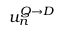<formula> <loc_0><loc_0><loc_500><loc_500>u _ { n } ^ { Q \rightarrow D }</formula> 